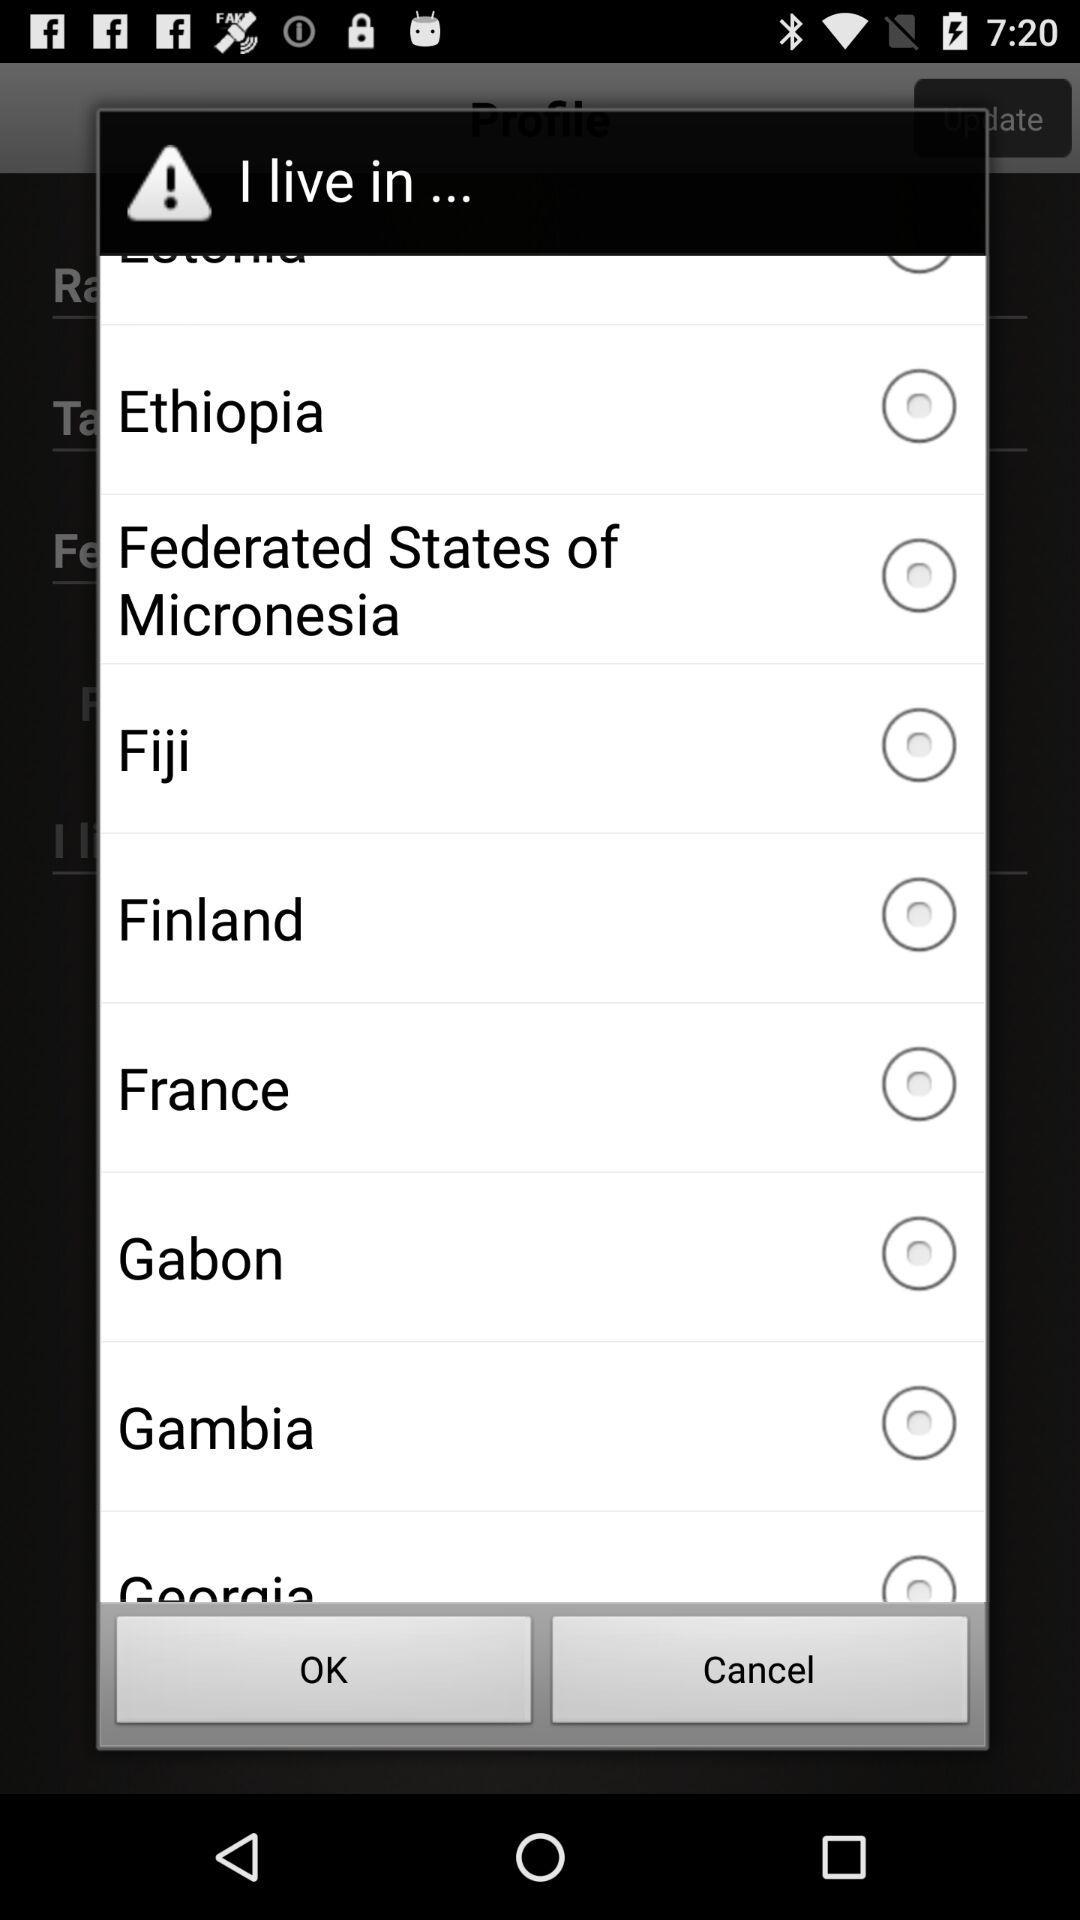Is "Ethiopia" selected or not? "Ethiopia" is not selected. 